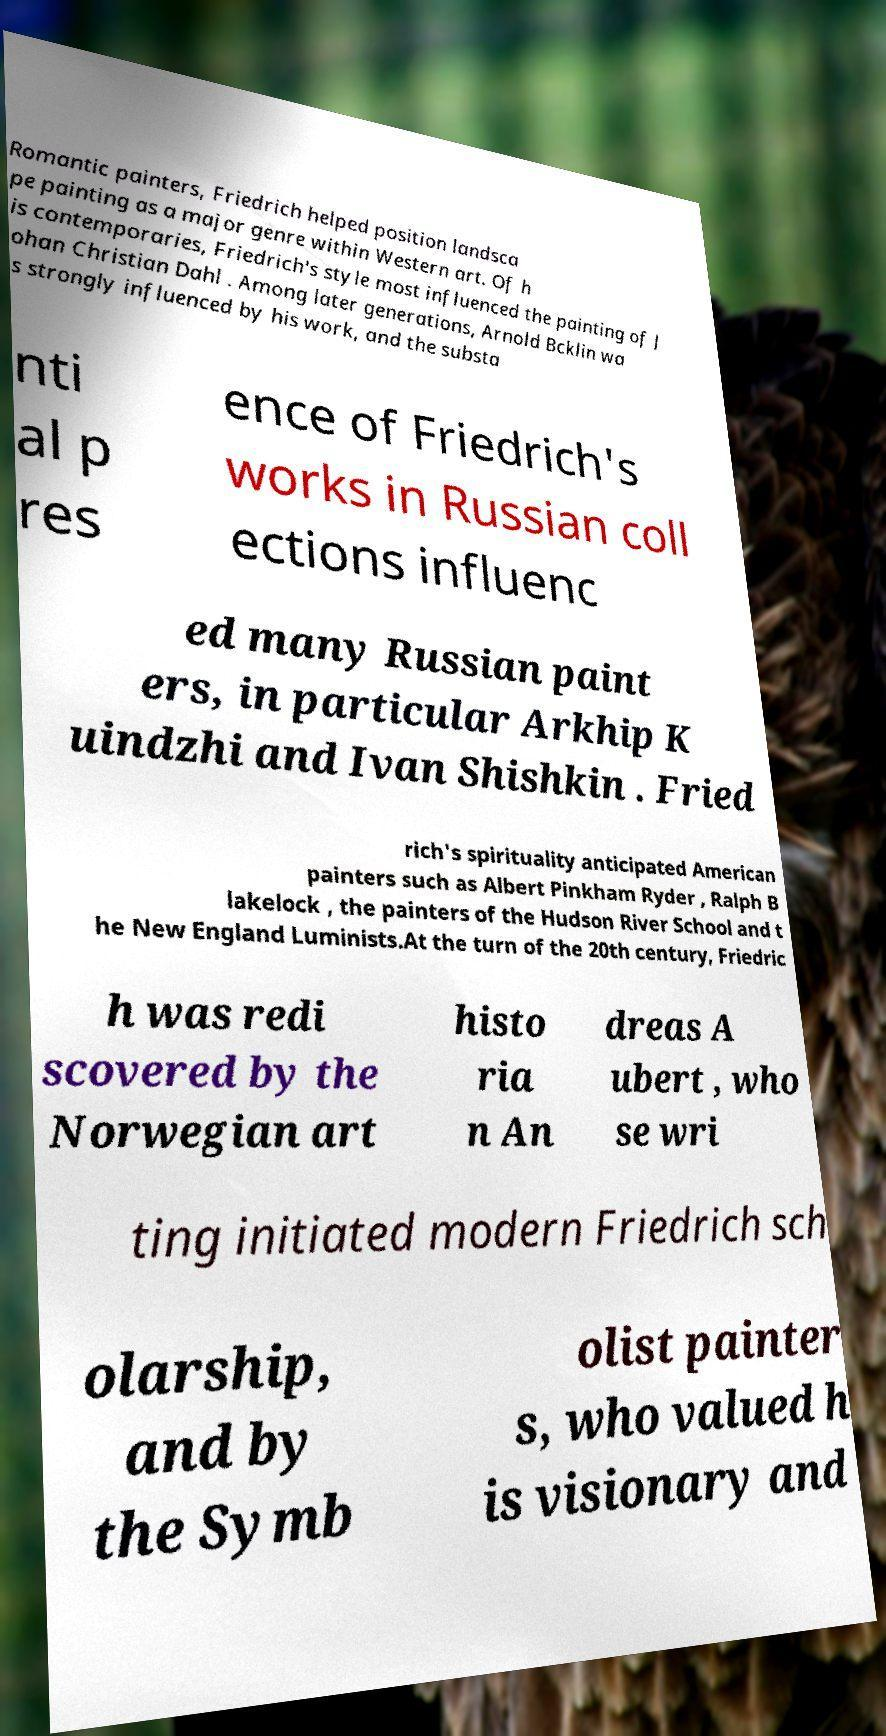Please read and relay the text visible in this image. What does it say? Romantic painters, Friedrich helped position landsca pe painting as a major genre within Western art. Of h is contemporaries, Friedrich's style most influenced the painting of J ohan Christian Dahl . Among later generations, Arnold Bcklin wa s strongly influenced by his work, and the substa nti al p res ence of Friedrich's works in Russian coll ections influenc ed many Russian paint ers, in particular Arkhip K uindzhi and Ivan Shishkin . Fried rich's spirituality anticipated American painters such as Albert Pinkham Ryder , Ralph B lakelock , the painters of the Hudson River School and t he New England Luminists.At the turn of the 20th century, Friedric h was redi scovered by the Norwegian art histo ria n An dreas A ubert , who se wri ting initiated modern Friedrich sch olarship, and by the Symb olist painter s, who valued h is visionary and 